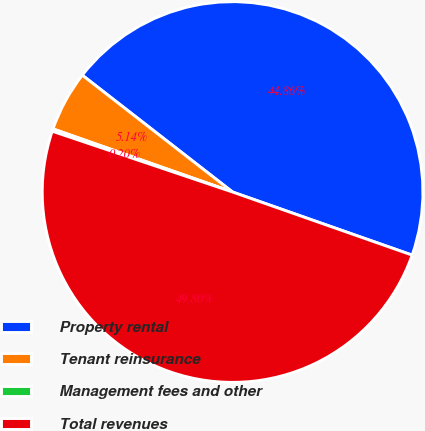Convert chart to OTSL. <chart><loc_0><loc_0><loc_500><loc_500><pie_chart><fcel>Property rental<fcel>Tenant reinsurance<fcel>Management fees and other<fcel>Total revenues<nl><fcel>44.86%<fcel>5.14%<fcel>0.2%<fcel>49.8%<nl></chart> 